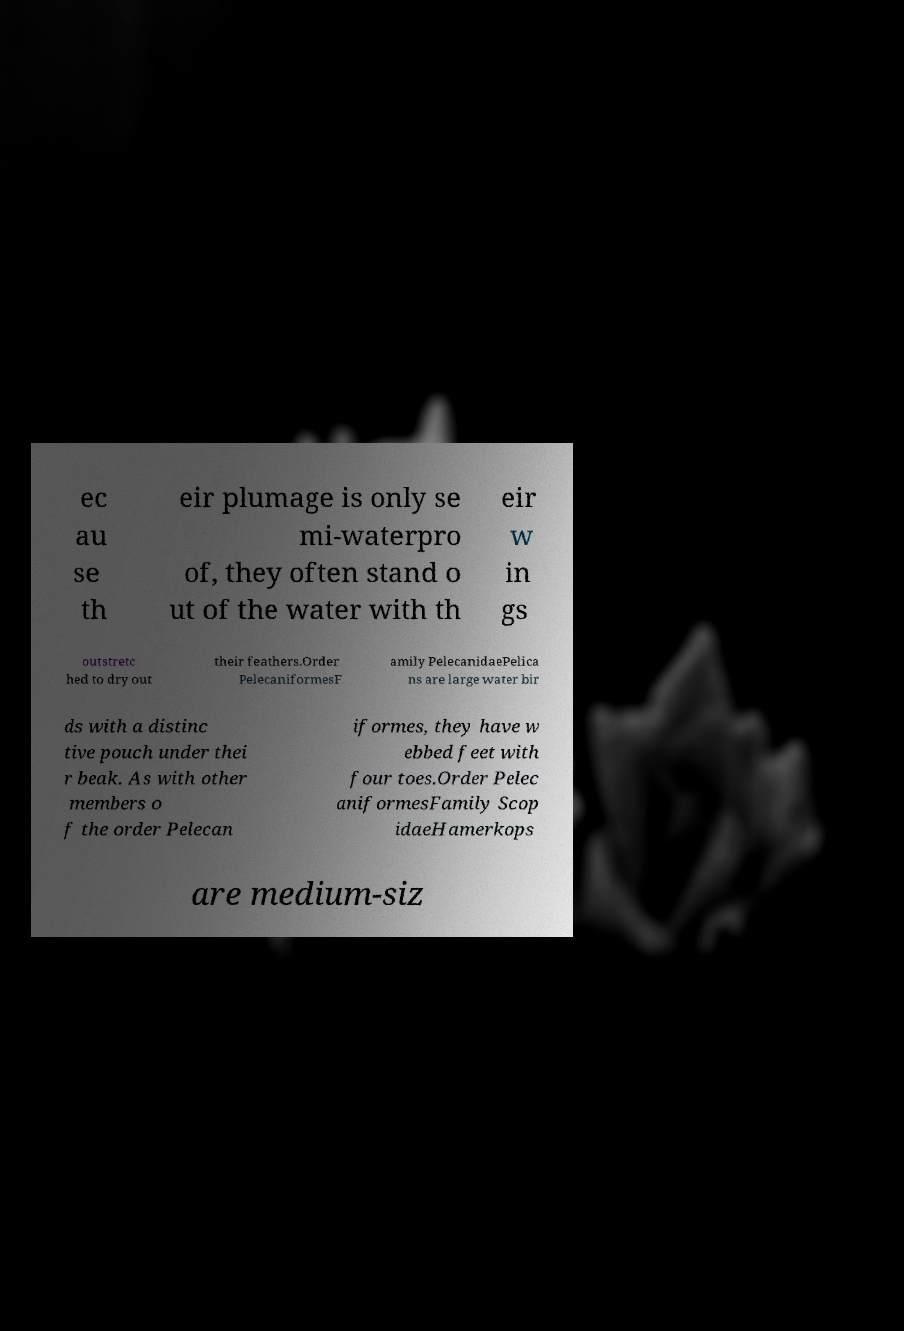What messages or text are displayed in this image? I need them in a readable, typed format. ec au se th eir plumage is only se mi-waterpro of, they often stand o ut of the water with th eir w in gs outstretc hed to dry out their feathers.Order PelecaniformesF amily PelecanidaePelica ns are large water bir ds with a distinc tive pouch under thei r beak. As with other members o f the order Pelecan iformes, they have w ebbed feet with four toes.Order Pelec aniformesFamily Scop idaeHamerkops are medium-siz 